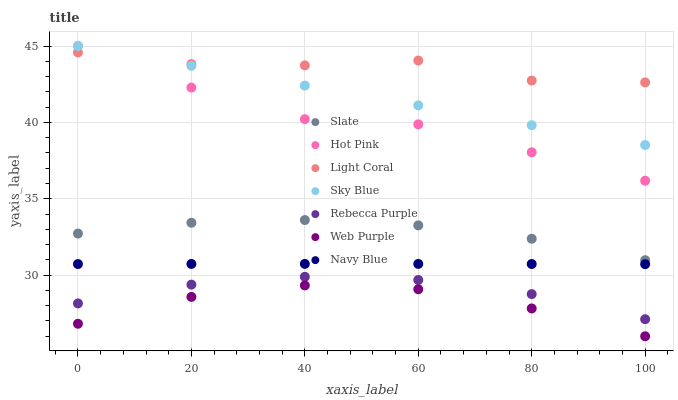Does Web Purple have the minimum area under the curve?
Answer yes or no. Yes. Does Light Coral have the maximum area under the curve?
Answer yes or no. Yes. Does Slate have the minimum area under the curve?
Answer yes or no. No. Does Slate have the maximum area under the curve?
Answer yes or no. No. Is Sky Blue the smoothest?
Answer yes or no. Yes. Is Hot Pink the roughest?
Answer yes or no. Yes. Is Slate the smoothest?
Answer yes or no. No. Is Slate the roughest?
Answer yes or no. No. Does Web Purple have the lowest value?
Answer yes or no. Yes. Does Slate have the lowest value?
Answer yes or no. No. Does Sky Blue have the highest value?
Answer yes or no. Yes. Does Slate have the highest value?
Answer yes or no. No. Is Web Purple less than Slate?
Answer yes or no. Yes. Is Sky Blue greater than Web Purple?
Answer yes or no. Yes. Does Hot Pink intersect Sky Blue?
Answer yes or no. Yes. Is Hot Pink less than Sky Blue?
Answer yes or no. No. Is Hot Pink greater than Sky Blue?
Answer yes or no. No. Does Web Purple intersect Slate?
Answer yes or no. No. 